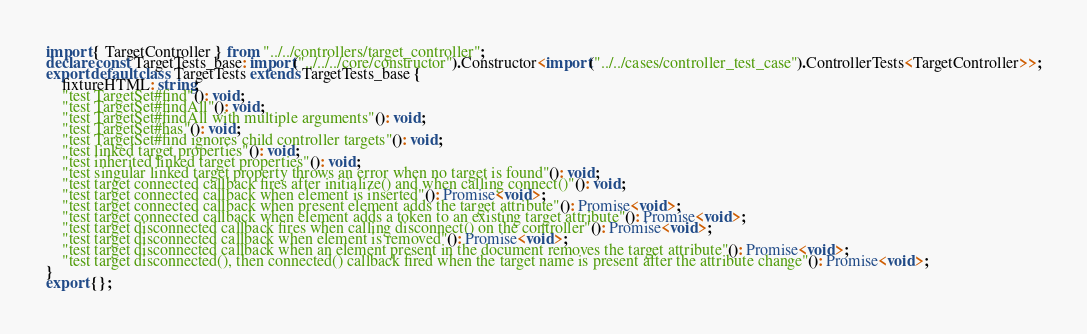Convert code to text. <code><loc_0><loc_0><loc_500><loc_500><_TypeScript_>import { TargetController } from "../../controllers/target_controller";
declare const TargetTests_base: import("../../../core/constructor").Constructor<import("../../cases/controller_test_case").ControllerTests<TargetController>>;
export default class TargetTests extends TargetTests_base {
    fixtureHTML: string;
    "test TargetSet#find"(): void;
    "test TargetSet#findAll"(): void;
    "test TargetSet#findAll with multiple arguments"(): void;
    "test TargetSet#has"(): void;
    "test TargetSet#find ignores child controller targets"(): void;
    "test linked target properties"(): void;
    "test inherited linked target properties"(): void;
    "test singular linked target property throws an error when no target is found"(): void;
    "test target connected callback fires after initialize() and when calling connect()"(): void;
    "test target connected callback when element is inserted"(): Promise<void>;
    "test target connected callback when present element adds the target attribute"(): Promise<void>;
    "test target connected callback when element adds a token to an existing target attribute"(): Promise<void>;
    "test target disconnected callback fires when calling disconnect() on the controller"(): Promise<void>;
    "test target disconnected callback when element is removed"(): Promise<void>;
    "test target disconnected callback when an element present in the document removes the target attribute"(): Promise<void>;
    "test target disconnected(), then connected() callback fired when the target name is present after the attribute change"(): Promise<void>;
}
export {};
</code> 